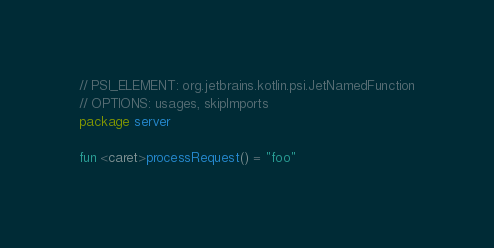<code> <loc_0><loc_0><loc_500><loc_500><_Kotlin_>// PSI_ELEMENT: org.jetbrains.kotlin.psi.JetNamedFunction
// OPTIONS: usages, skipImports
package server

fun <caret>processRequest() = "foo"

</code> 